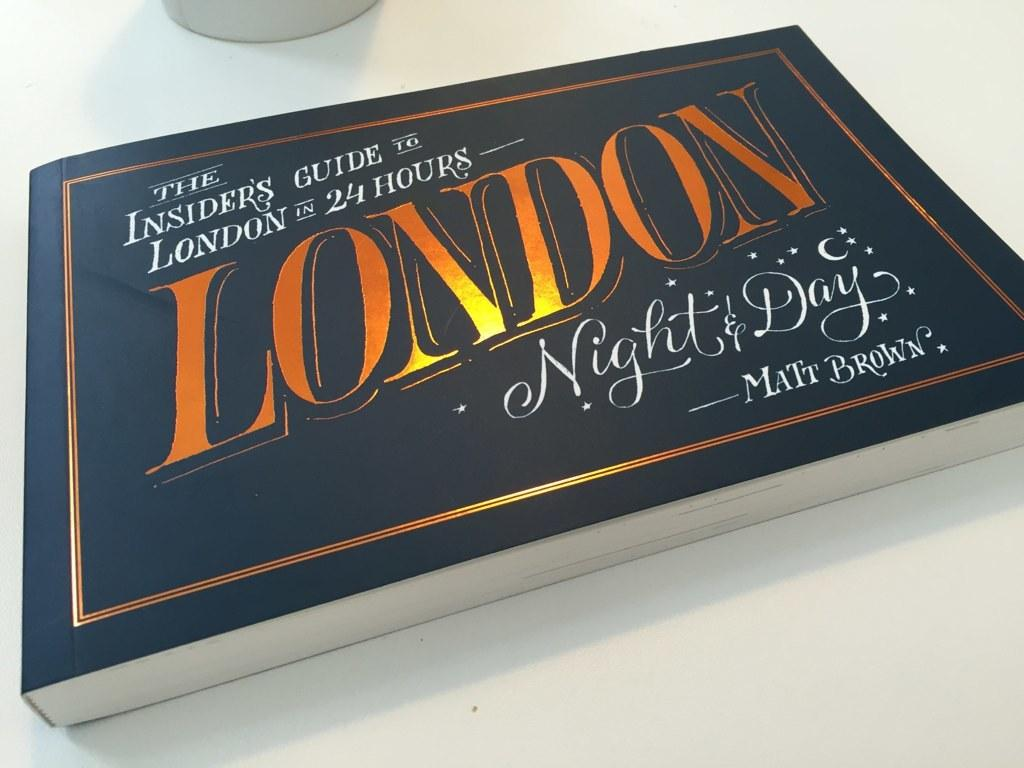<image>
Give a short and clear explanation of the subsequent image. A book by Matt Brown that contains ideas on what to do with a day and night in London. 